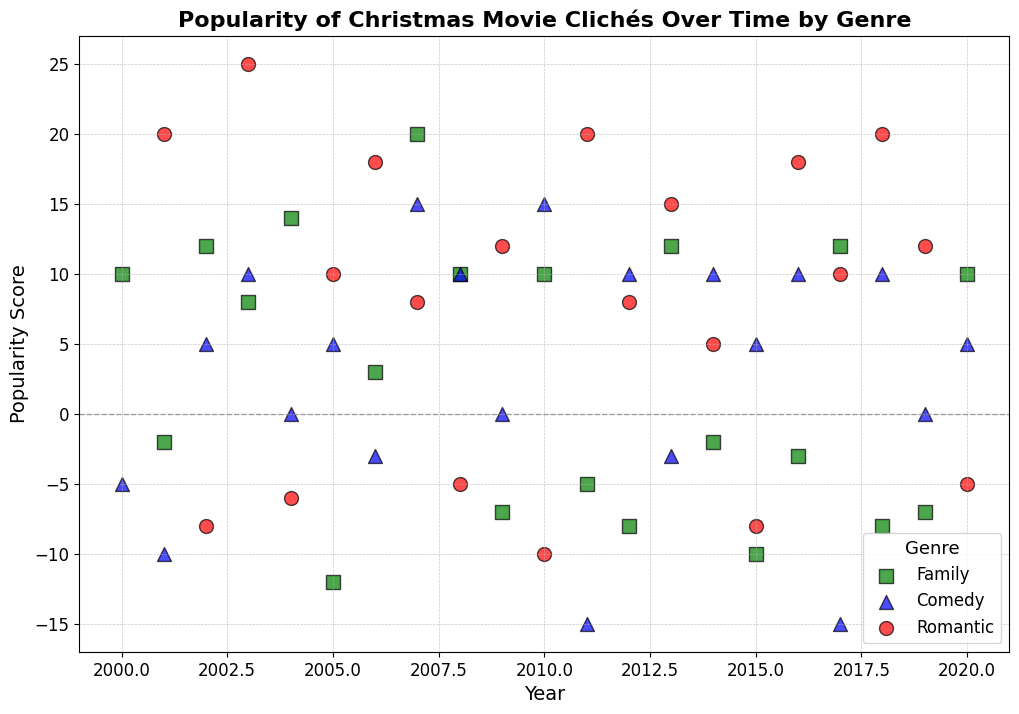What trend do you observe in the popularity of Romantic Christmas movie clichés over time? To answer this, we'll look at the red dots (Romantic genre) in the scatter plot and observe how their y-values (Popularity_Score) change from 2000 to 2020. Starting from 2001's high of 20, scores fluctuate but generally show an increasing trend towards high popularity in later years, with peaks in 2003 and 2011.
Answer: Increasing trend with fluctuations What year saw the highest popularity for Family Christmas movie clichés and what cliché was it? We examine the green squares (Family genre) for the highest y-value. The highest popularity for Family clichés occurs in 2007 with a score of 20. By referencing the data, the cliché is "Home Alone".
Answer: 2007, Home Alone In which years did Comedy Christmas movie clichés have a negative popularity score? We'll identify the blue triangles (Comedy genre) with negative y-values. From the scatter plot, these years are 2001, 2004, 2006, 2011, 2013, 2015, and 2017.
Answer: 2001, 2004, 2006, 2011, 2013, 2015, 2017 Which genre shows the most variability in the popularity scores of their Christmas clichés over the years? We compare the spread of y-values for each genre: red dots (Romantic), green squares (Family), and blue triangles (Comedy). The widest range is observed in Romantic clichés, spanning from -10 to 25.
Answer: Romantic How does the popularity of "Snowed-In Romance" in 2006 compare to "Surprise Christmas Carriage Ride" in 2016? Referencing the plot, the "Snowed-In Romance" point for 2006 has a score of 18, while "Surprise Christmas Carriage Ride" for 2016 also has a score of 18.
Answer: 18 vs. 18, equal Which genre has the largest number of clichés with negative popularity scores? By counting each genre's negative y-values, Family has fewer negatives compared to Romantic and Comedy, with Comedy showing the highest variability in negative scores.
Answer: Comedy What is the average popularity score for Family clichés in 2010? Only one Family cliché in 2010: "Holiday Road Trips" with a score of 10. So the average popularity score is 10/1 = 10.
Answer: 10 Which year exhibits the highest diversity in Comedy clichés' popularity scores? We identify the year with the widest spread of y-values for blue triangles (Comedy). 2007 stands out with the highest score of 15 for "Elves Gone Wild" and other years lack such a large variance.
Answer: 2007 